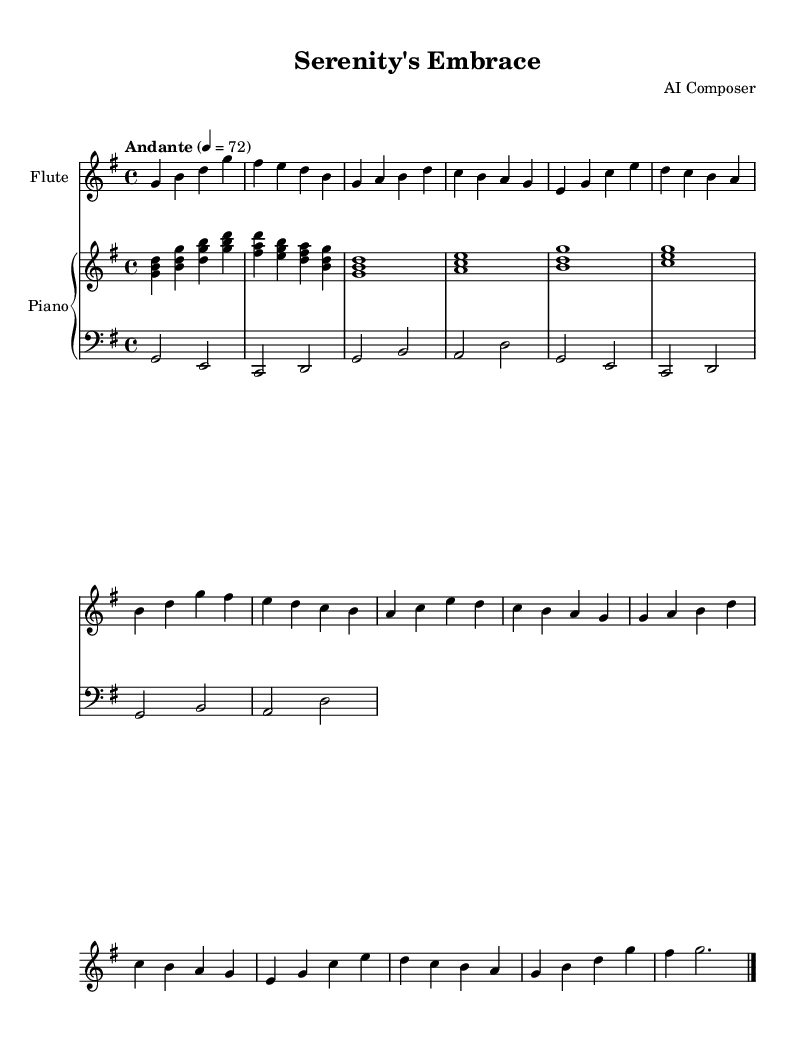What is the key signature of this music? The key signature consists of one sharp, indicating that the key is G major. This can be identified by looking at the beginning of the staff, where the sharp is placed on the F line.
Answer: G major What is the time signature? The time signature is indicated at the beginning of the piece, showing that there are 4 beats per measure, which is represented by 4 over 4.
Answer: 4/4 What is the tempo marking? The tempo marking written at the top indicates a moderate pace, specifically "Andante," which often refers to a walking speed. It is followed by a metronome marking of 72 beats per minute.
Answer: Andante What instrument is primarily featured in this score? The title of the score and the presence of the flute staff indicates that the flute is the primary instrument being featured. The name appears prominently at the beginning of the flute staff.
Answer: Flute How many sections are there in this piece? The piece includes an intro, two main sections marked "A" and "B," and a coda, totaling four sections. Each section can be identified from the annotations in the music.
Answer: Four sections Which phrase is repeated in this composition? The phrase labeled "A'" is the repeated section of music after the initial "A" section, indicating that it is a variation or repetition of the first phrase. This repetition is a common structure in romantic music.
Answer: A' What is the duration of the last note in the flute part? The last note in the flute part is a half note, which is indicated by its shape and duration markings, and is held for a longer period compared to quarter notes present in the rest of the music.
Answer: Half note 